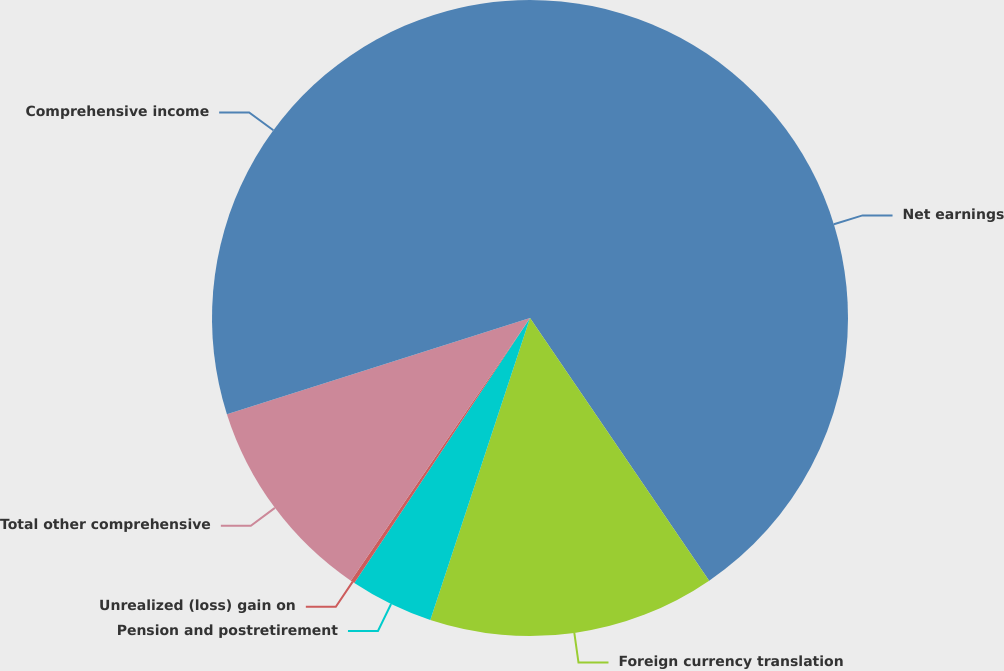Convert chart to OTSL. <chart><loc_0><loc_0><loc_500><loc_500><pie_chart><fcel>Net earnings<fcel>Foreign currency translation<fcel>Pension and postretirement<fcel>Unrealized (loss) gain on<fcel>Total other comprehensive<fcel>Comprehensive income<nl><fcel>40.47%<fcel>14.6%<fcel>4.24%<fcel>0.21%<fcel>10.58%<fcel>29.89%<nl></chart> 